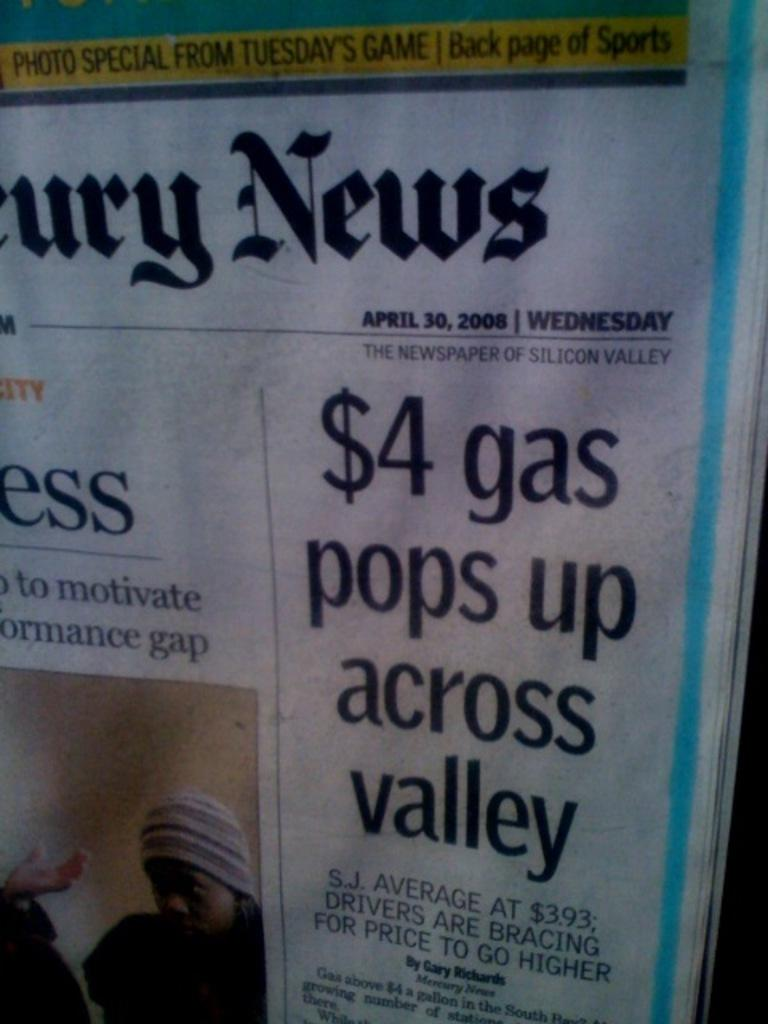What is the main object in the image? There is a newspaper in the image. What type of content can be found in the newspaper? The newspaper contains text. Is there any visual element in the newspaper? Yes, there is an image of two persons in the newspaper. What organization is responsible for the thrilling cause depicted in the image? There is no organization or thrilling cause depicted in the image; it only contains a newspaper with text and an image of two persons. 